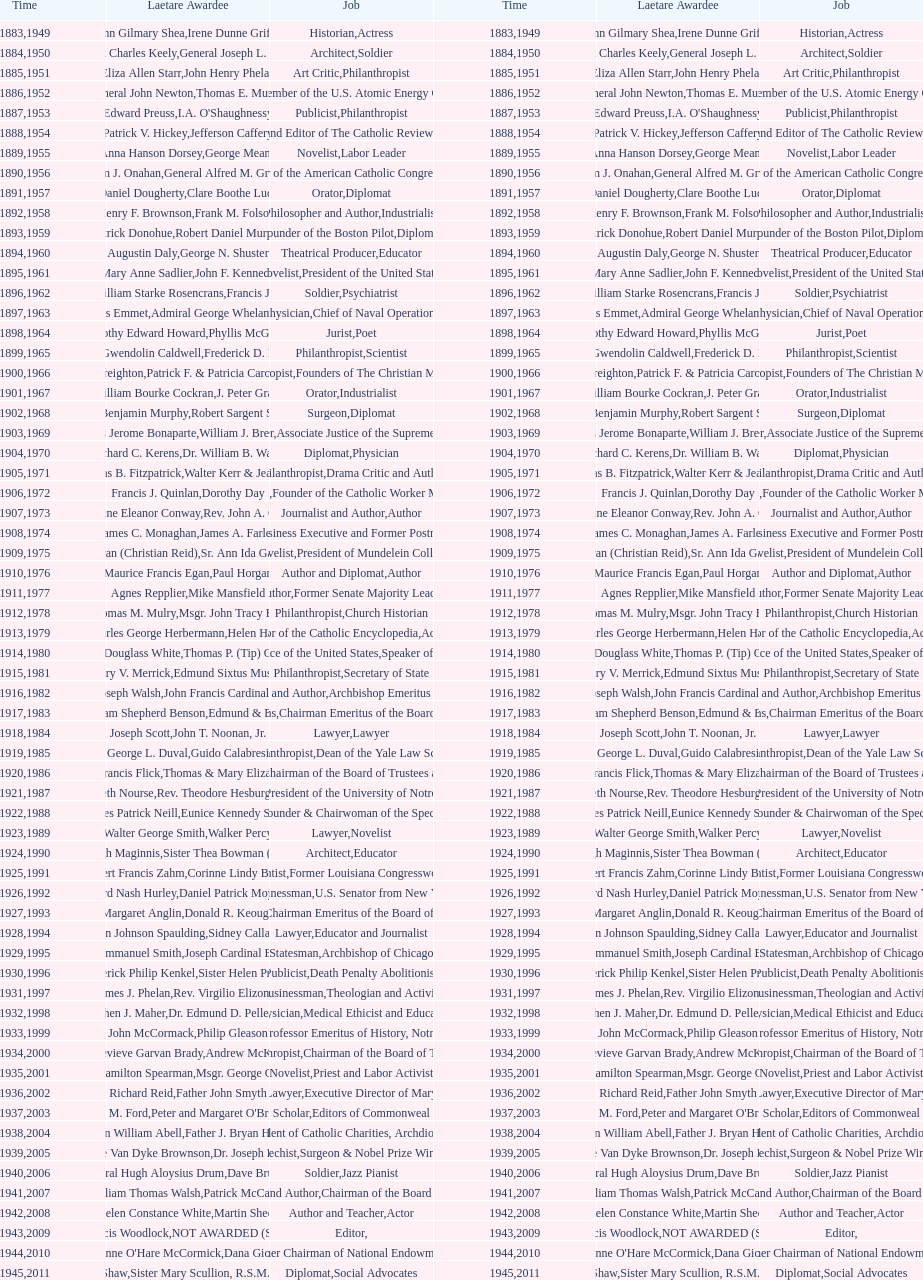How many times does philanthropist appear in the position column on this chart? 9. Help me parse the entirety of this table. {'header': ['Time', 'Laetare Awardee', 'Job', 'Time', 'Laetare Awardee', 'Job'], 'rows': [['1883', 'John Gilmary Shea', 'Historian', '1949', 'Irene Dunne Griffin', 'Actress'], ['1884', 'Patrick Charles Keely', 'Architect', '1950', 'General Joseph L. Collins', 'Soldier'], ['1885', 'Eliza Allen Starr', 'Art Critic', '1951', 'John Henry Phelan', 'Philanthropist'], ['1886', 'General John Newton', 'Engineer', '1952', 'Thomas E. Murray', 'Member of the U.S. Atomic Energy Commission'], ['1887', 'Edward Preuss', 'Publicist', '1953', "I.A. O'Shaughnessy", 'Philanthropist'], ['1888', 'Patrick V. Hickey', 'Founder and Editor of The Catholic Review', '1954', 'Jefferson Caffery', 'Diplomat'], ['1889', 'Anna Hanson Dorsey', 'Novelist', '1955', 'George Meany', 'Labor Leader'], ['1890', 'William J. Onahan', 'Organizer of the American Catholic Congress', '1956', 'General Alfred M. Gruenther', 'Soldier'], ['1891', 'Daniel Dougherty', 'Orator', '1957', 'Clare Boothe Luce', 'Diplomat'], ['1892', 'Henry F. Brownson', 'Philosopher and Author', '1958', 'Frank M. Folsom', 'Industrialist'], ['1893', 'Patrick Donohue', 'Founder of the Boston Pilot', '1959', 'Robert Daniel Murphy', 'Diplomat'], ['1894', 'Augustin Daly', 'Theatrical Producer', '1960', 'George N. Shuster', 'Educator'], ['1895', 'Mary Anne Sadlier', 'Novelist', '1961', 'John F. Kennedy', 'President of the United States'], ['1896', 'General William Starke Rosencrans', 'Soldier', '1962', 'Francis J. Braceland', 'Psychiatrist'], ['1897', 'Thomas Addis Emmet', 'Physician', '1963', 'Admiral George Whelan Anderson, Jr.', 'Chief of Naval Operations'], ['1898', 'Timothy Edward Howard', 'Jurist', '1964', 'Phyllis McGinley', 'Poet'], ['1899', 'Mary Gwendolin Caldwell', 'Philanthropist', '1965', 'Frederick D. Rossini', 'Scientist'], ['1900', 'John A. Creighton', 'Philanthropist', '1966', 'Patrick F. & Patricia Caron Crowley', 'Founders of The Christian Movement'], ['1901', 'William Bourke Cockran', 'Orator', '1967', 'J. Peter Grace', 'Industrialist'], ['1902', 'John Benjamin Murphy', 'Surgeon', '1968', 'Robert Sargent Shriver', 'Diplomat'], ['1903', 'Charles Jerome Bonaparte', 'Lawyer', '1969', 'William J. Brennan Jr.', 'Associate Justice of the Supreme Court'], ['1904', 'Richard C. Kerens', 'Diplomat', '1970', 'Dr. William B. Walsh', 'Physician'], ['1905', 'Thomas B. Fitzpatrick', 'Philanthropist', '1971', 'Walter Kerr & Jean Kerr', 'Drama Critic and Author'], ['1906', 'Francis J. Quinlan', 'Physician', '1972', 'Dorothy Day', 'Founder of the Catholic Worker Movement'], ['1907', 'Katherine Eleanor Conway', 'Journalist and Author', '1973', "Rev. John A. O'Brien", 'Author'], ['1908', 'James C. Monaghan', 'Economist', '1974', 'James A. Farley', 'Business Executive and Former Postmaster General'], ['1909', 'Frances Tieran (Christian Reid)', 'Novelist', '1975', 'Sr. Ann Ida Gannon, BMV', 'President of Mundelein College'], ['1910', 'Maurice Francis Egan', 'Author and Diplomat', '1976', 'Paul Horgan', 'Author'], ['1911', 'Agnes Repplier', 'Author', '1977', 'Mike Mansfield', 'Former Senate Majority Leader'], ['1912', 'Thomas M. Mulry', 'Philanthropist', '1978', 'Msgr. John Tracy Ellis', 'Church Historian'], ['1913', 'Charles George Herbermann', 'Editor of the Catholic Encyclopedia', '1979', 'Helen Hayes', 'Actress'], ['1914', 'Edward Douglass White', 'Chief Justice of the United States', '1980', "Thomas P. (Tip) O'Neill Jr.", 'Speaker of the House'], ['1915', 'Mary V. Merrick', 'Philanthropist', '1981', 'Edmund Sixtus Muskie', 'Secretary of State'], ['1916', 'James Joseph Walsh', 'Physician and Author', '1982', 'John Francis Cardinal Dearden', 'Archbishop Emeritus of Detroit'], ['1917', 'Admiral William Shepherd Benson', 'Chief of Naval Operations', '1983', 'Edmund & Evelyn Stephan', 'Chairman Emeritus of the Board of Trustees and his wife'], ['1918', 'Joseph Scott', 'Lawyer', '1984', 'John T. Noonan, Jr.', 'Lawyer'], ['1919', 'George L. Duval', 'Philanthropist', '1985', 'Guido Calabresi', 'Dean of the Yale Law School'], ['1920', 'Lawrence Francis Flick', 'Physician', '1986', 'Thomas & Mary Elizabeth Carney', 'Chairman of the Board of Trustees and his wife'], ['1921', 'Elizabeth Nourse', 'Artist', '1987', 'Rev. Theodore Hesburgh, CSC', 'President of the University of Notre Dame'], ['1922', 'Charles Patrick Neill', 'Economist', '1988', 'Eunice Kennedy Shriver', 'Founder & Chairwoman of the Special Olympics'], ['1923', 'Walter George Smith', 'Lawyer', '1989', 'Walker Percy', 'Novelist'], ['1924', 'Charles Donagh Maginnis', 'Architect', '1990', 'Sister Thea Bowman (posthumously)', 'Educator'], ['1925', 'Albert Francis Zahm', 'Scientist', '1991', 'Corinne Lindy Boggs', 'Former Louisiana Congresswoman'], ['1926', 'Edward Nash Hurley', 'Businessman', '1992', 'Daniel Patrick Moynihan', 'U.S. Senator from New York'], ['1927', 'Margaret Anglin', 'Actress', '1993', 'Donald R. Keough', 'Chairman Emeritus of the Board of Trustees'], ['1928', 'John Johnson Spaulding', 'Lawyer', '1994', 'Sidney Callahan', 'Educator and Journalist'], ['1929', 'Alfred Emmanuel Smith', 'Statesman', '1995', 'Joseph Cardinal Bernardin', 'Archbishop of Chicago'], ['1930', 'Frederick Philip Kenkel', 'Publicist', '1996', 'Sister Helen Prejean', 'Death Penalty Abolitionist'], ['1931', 'James J. Phelan', 'Businessman', '1997', 'Rev. Virgilio Elizondo', 'Theologian and Activist'], ['1932', 'Stephen J. Maher', 'Physician', '1998', 'Dr. Edmund D. Pellegrino', 'Medical Ethicist and Educator'], ['1933', 'John McCormack', 'Artist', '1999', 'Philip Gleason', 'Professor Emeritus of History, Notre Dame'], ['1934', 'Genevieve Garvan Brady', 'Philanthropist', '2000', 'Andrew McKenna', 'Chairman of the Board of Trustees'], ['1935', 'Francis Hamilton Spearman', 'Novelist', '2001', 'Msgr. George G. Higgins', 'Priest and Labor Activist'], ['1936', 'Richard Reid', 'Journalist and Lawyer', '2002', 'Father John Smyth', 'Executive Director of Maryville Academy'], ['1937', 'Jeremiah D. M. Ford', 'Scholar', '2003', "Peter and Margaret O'Brien Steinfels", 'Editors of Commonweal'], ['1938', 'Irvin William Abell', 'Surgeon', '2004', 'Father J. Bryan Hehir', 'President of Catholic Charities, Archdiocese of Boston'], ['1939', 'Josephine Van Dyke Brownson', 'Catechist', '2005', 'Dr. Joseph E. Murray', 'Surgeon & Nobel Prize Winner'], ['1940', 'General Hugh Aloysius Drum', 'Soldier', '2006', 'Dave Brubeck', 'Jazz Pianist'], ['1941', 'William Thomas Walsh', 'Journalist and Author', '2007', 'Patrick McCartan', 'Chairman of the Board of Trustees'], ['1942', 'Helen Constance White', 'Author and Teacher', '2008', 'Martin Sheen', 'Actor'], ['1943', 'Thomas Francis Woodlock', 'Editor', '2009', 'NOT AWARDED (SEE BELOW)', ''], ['1944', "Anne O'Hare McCormick", 'Journalist', '2010', 'Dana Gioia', 'Former Chairman of National Endowment for the Arts'], ['1945', 'Gardiner Howland Shaw', 'Diplomat', '2011', 'Sister Mary Scullion, R.S.M., & Joan McConnon', 'Social Advocates'], ['1946', 'Carlton J. H. Hayes', 'Historian and Diplomat', '2012', 'Ken Hackett', 'Former President of Catholic Relief Services'], ['1947', 'William G. Bruce', 'Publisher and Civic Leader', '2013', 'Sister Susanne Gallagher, S.P.\\nSister Mary Therese Harrington, S.H.\\nRev. James H. McCarthy', 'Founders of S.P.R.E.D. (Special Religious Education Development Network)'], ['1948', 'Frank C. Walker', 'Postmaster General and Civic Leader', '2014', 'Kenneth R. Miller', 'Professor of Biology at Brown University']]} 